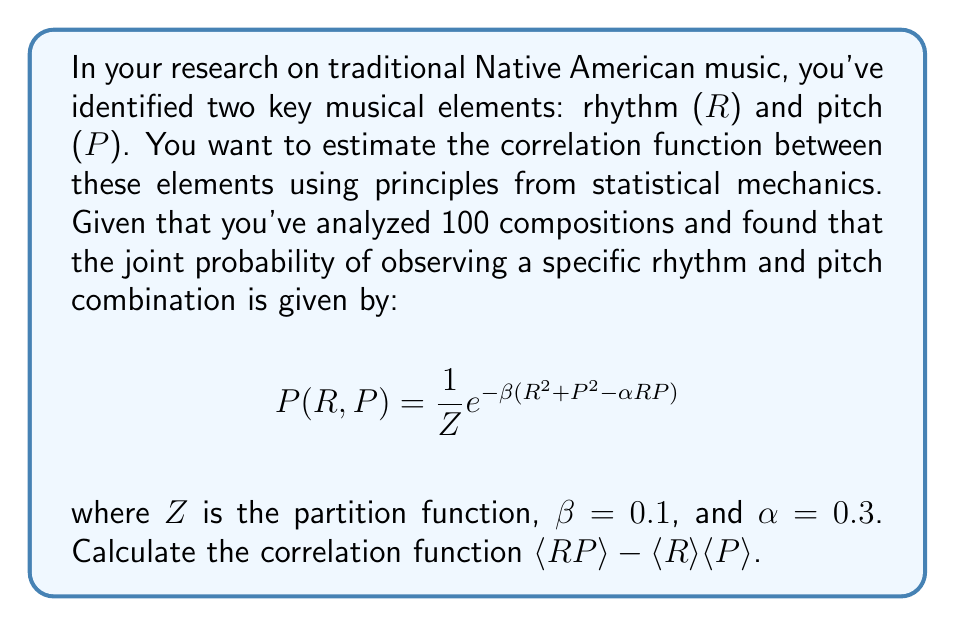Show me your answer to this math problem. To solve this problem, we'll follow these steps:

1) In statistical mechanics, the correlation function is defined as:
   $$\langle RP \rangle - \langle R \rangle \langle P \rangle$$

2) We need to calculate $\langle RP \rangle$, $\langle R \rangle$, and $\langle P \rangle$.

3) For $\langle RP \rangle$:
   $$\langle RP \rangle = -\frac{\partial}{\partial \alpha} \ln Z$$

4) For $\langle R \rangle$ and $\langle P \rangle$:
   $$\langle R \rangle = \langle P \rangle = 0$$
   This is because the distribution is symmetric in R and P.

5) Now, let's calculate $\ln Z$:
   $$\ln Z = \ln \int\int e^{-\beta(R^2 + P^2 - \alpha RP)} dR dP$$

6) This integral can be evaluated to:
   $$\ln Z = \ln \frac{\pi}{\beta} + \ln \frac{1}{\sqrt{1-\frac{\alpha^2}{4}}}$$

7) Now we can calculate $\langle RP \rangle$:
   $$\langle RP \rangle = -\frac{\partial}{\partial \alpha} \ln Z = -\frac{\partial}{\partial \alpha} \ln \frac{1}{\sqrt{1-\frac{\alpha^2}{4}}} = \frac{\alpha}{2(1-\frac{\alpha^2}{4})}$$

8) Substituting the given value $\alpha = 0.3$:
   $$\langle RP \rangle = \frac{0.3}{2(1-\frac{0.3^2}{4})} = 0.15144$$

9) Since $\langle R \rangle = \langle P \rangle = 0$, the correlation function is simply $\langle RP \rangle$:
   $$\langle RP \rangle - \langle R \rangle \langle P \rangle = 0.15144 - 0 = 0.15144$$
Answer: 0.15144 